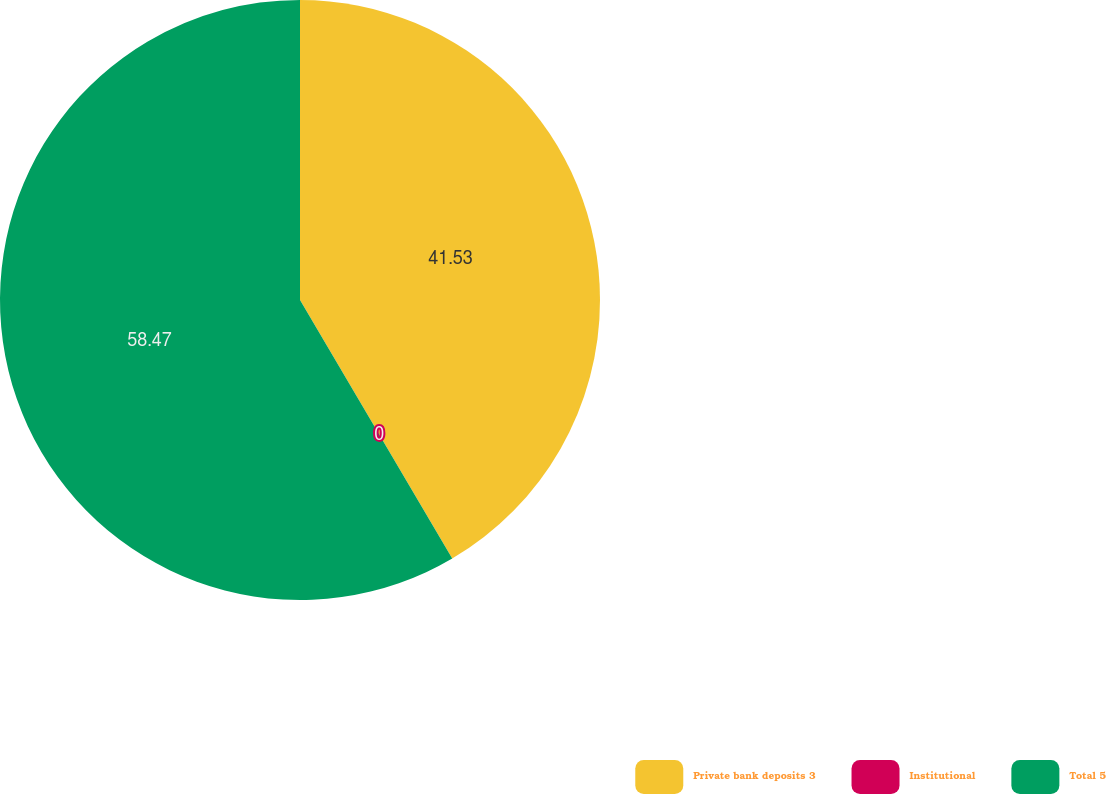<chart> <loc_0><loc_0><loc_500><loc_500><pie_chart><fcel>Private bank deposits 3<fcel>Institutional<fcel>Total 5<nl><fcel>41.53%<fcel>0.0%<fcel>58.47%<nl></chart> 